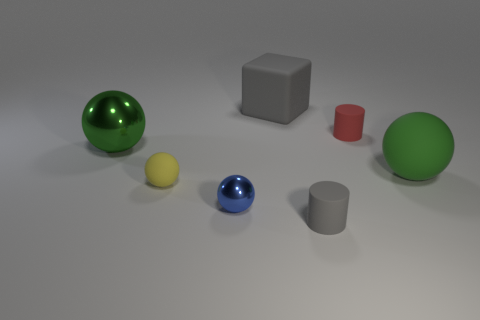Subtract all purple blocks. How many green spheres are left? 2 Add 1 tiny brown rubber balls. How many objects exist? 8 Subtract all small blue shiny spheres. How many spheres are left? 3 Subtract 2 balls. How many balls are left? 2 Subtract all blue balls. How many balls are left? 3 Subtract all balls. How many objects are left? 3 Subtract 2 green spheres. How many objects are left? 5 Subtract all gray balls. Subtract all red blocks. How many balls are left? 4 Subtract all green matte cylinders. Subtract all big green matte things. How many objects are left? 6 Add 1 blue shiny objects. How many blue shiny objects are left? 2 